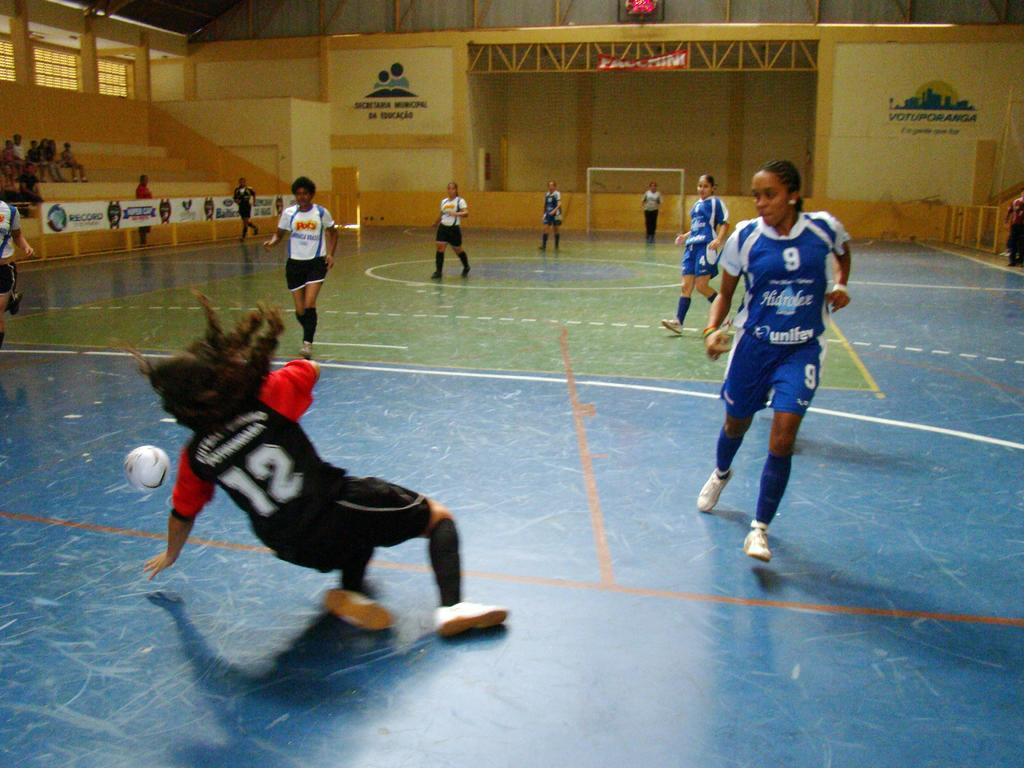<image>
Present a compact description of the photo's key features. Indoor soccer gym with a sign on the right wall that has VOTUPORANGA in dark letters. 